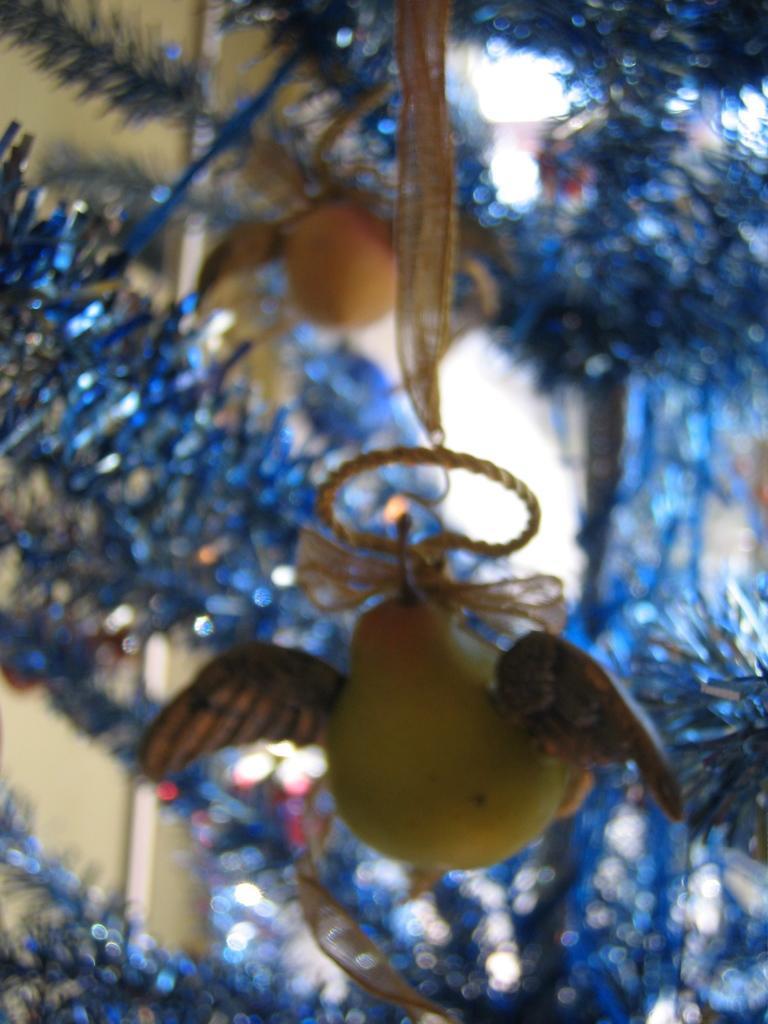Please provide a concise description of this image. Here in this picture we can see a Christmas tree decorated all over there and in the front we can see a fruit hanging with wings on it over there. 